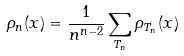<formula> <loc_0><loc_0><loc_500><loc_500>\rho _ { n } ( x ) = \frac { 1 } { n ^ { n - 2 } } \sum _ { T _ { n } } \rho _ { T _ { n } } ( x )</formula> 